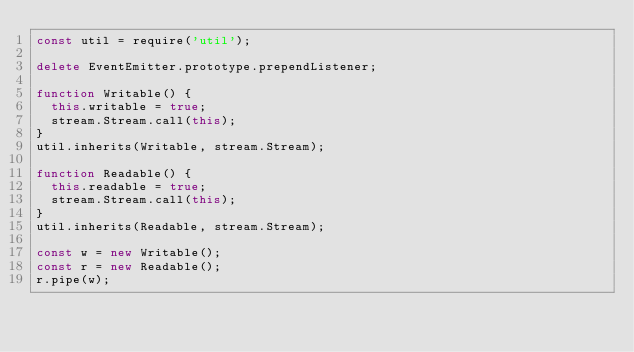Convert code to text. <code><loc_0><loc_0><loc_500><loc_500><_JavaScript_>const util = require('util');

delete EventEmitter.prototype.prependListener;

function Writable() {
  this.writable = true;
  stream.Stream.call(this);
}
util.inherits(Writable, stream.Stream);

function Readable() {
  this.readable = true;
  stream.Stream.call(this);
}
util.inherits(Readable, stream.Stream);

const w = new Writable();
const r = new Readable();
r.pipe(w);
</code> 